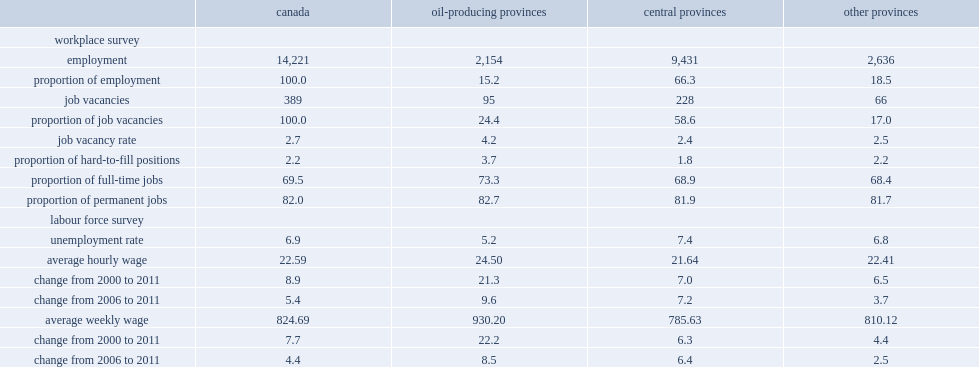What was the proportion of job vacancies (%) in the oil-producing provinces? 24.4. What was the proportion of job vacancies (%) in the central provinces? 58.6. What was the proportion of job vacancies (%) in the other provinces? 17.0. Which province had the highest job vacancy rate in december 2011? Oil-producing provinces. What were the unemployment rates for oil-producing provinces,central provinces and elsewhere respectively? 5.2 7.4 6.8. Which province had the highest proportion of hard-to-fill positions? Oil-producing provinces. What were the percentages of average hourly wages increased between 2000 and 2011 in the oil-producing provinces, central provinces and other provincial groups respectively? 21.3 7.0 6.5. Which province had the highest proportion of full-time jobs? Oil-producing provinces. 